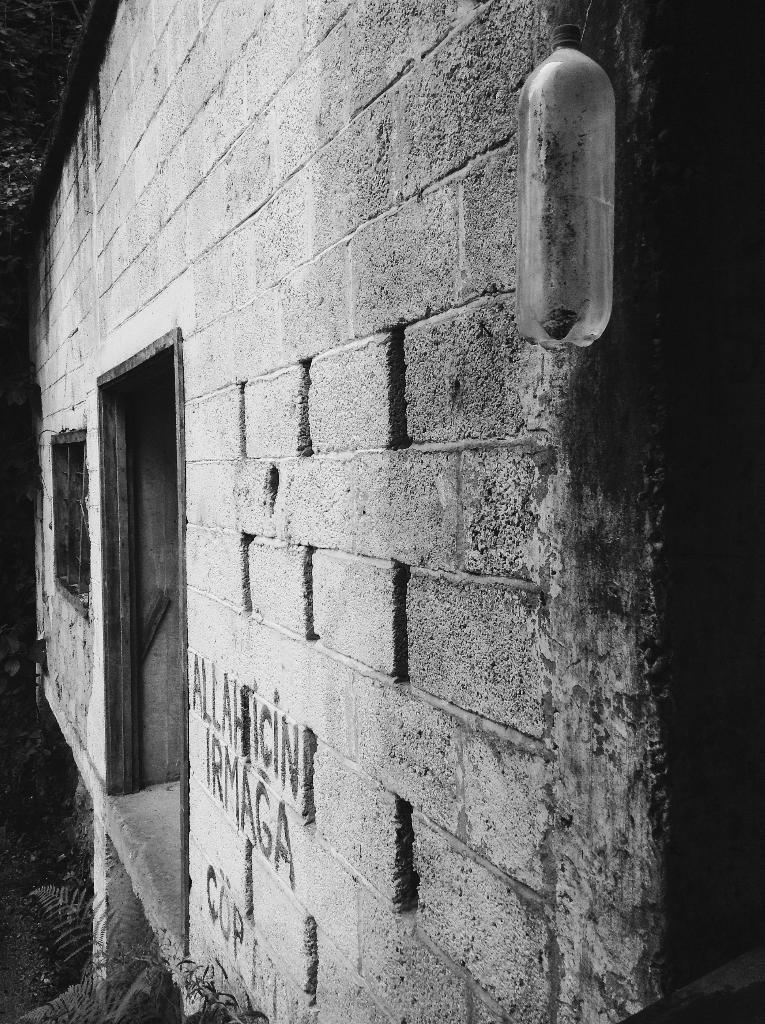What type of structure can be seen in the image? There is a wall in the image. What object is present in the image besides the wall? There is a bottle in the image. How many beds are visible in the image? There are no beds present in the image. What type of writing instrument is used by the tree in the image? There are no trees or writing instruments present in the image. 